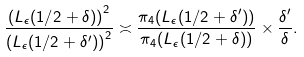Convert formula to latex. <formula><loc_0><loc_0><loc_500><loc_500>\frac { \left ( L _ { \epsilon } ( 1 / 2 + \delta ) \right ) ^ { 2 } } { \left ( L _ { \epsilon } ( 1 / 2 + \delta ^ { \prime } ) \right ) ^ { 2 } } \asymp \frac { \pi _ { 4 } ( L _ { \epsilon } ( 1 / 2 + \delta ^ { \prime } ) ) } { \pi _ { 4 } ( L _ { \epsilon } ( 1 / 2 + \delta ) ) } \times \frac { \delta ^ { \prime } } { \delta } .</formula> 